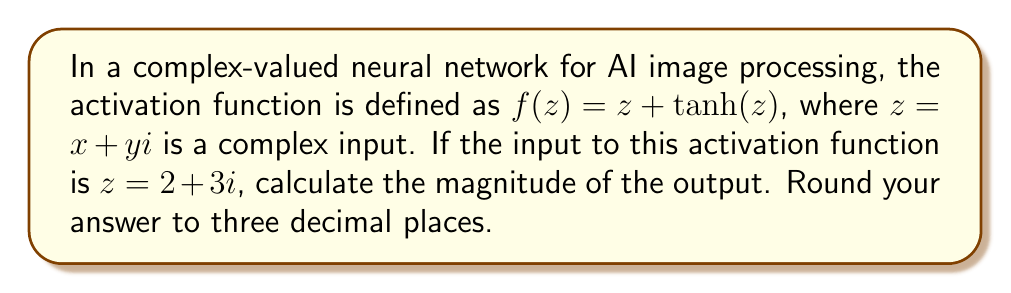Give your solution to this math problem. Let's approach this step-by-step:

1) We start with the activation function $f(z) = z + \tanh(z)$, where $z = 2 + 3i$.

2) First, let's calculate $\tanh(z)$:
   $\tanh(z) = \frac{\sinh(z)}{\cosh(z)} = \frac{e^z - e^{-z}}{e^z + e^{-z}}$

3) For complex numbers, we can express this as:
   $\tanh(x+yi) = \frac{\sinh(x)\cos(y) + i\cosh(x)\sin(y)}{\cosh(x)\cos(y) + i\sinh(x)\sin(y)}$

4) Substituting $x=2$ and $y=3$:
   $\tanh(2+3i) \approx 0.9653 + 0.0097i$ (rounded to 4 decimal places)

5) Now, we can calculate $f(z)$:
   $f(2+3i) = (2+3i) + (0.9653 + 0.0097i)$
            $= 2.9653 + 3.0097i$

6) To find the magnitude of this complex number, we use the formula:
   $|a+bi| = \sqrt{a^2 + b^2}$

7) Therefore, the magnitude is:
   $\sqrt{2.9653^2 + 3.0097^2} \approx 4.233$
Answer: 4.233 